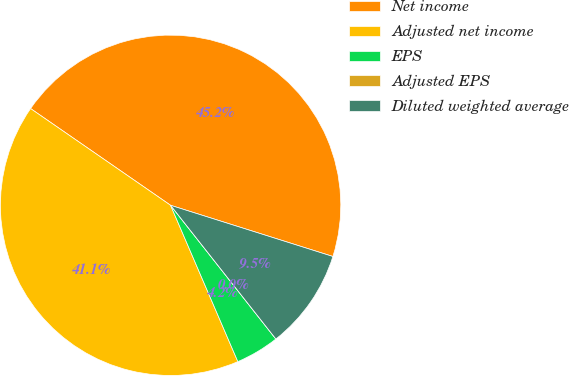Convert chart to OTSL. <chart><loc_0><loc_0><loc_500><loc_500><pie_chart><fcel>Net income<fcel>Adjusted net income<fcel>EPS<fcel>Adjusted EPS<fcel>Diluted weighted average<nl><fcel>45.24%<fcel>41.09%<fcel>4.15%<fcel>0.0%<fcel>9.52%<nl></chart> 